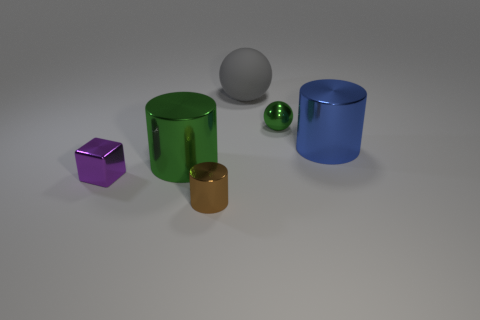There is a purple object that is the same size as the brown object; what shape is it? cube 